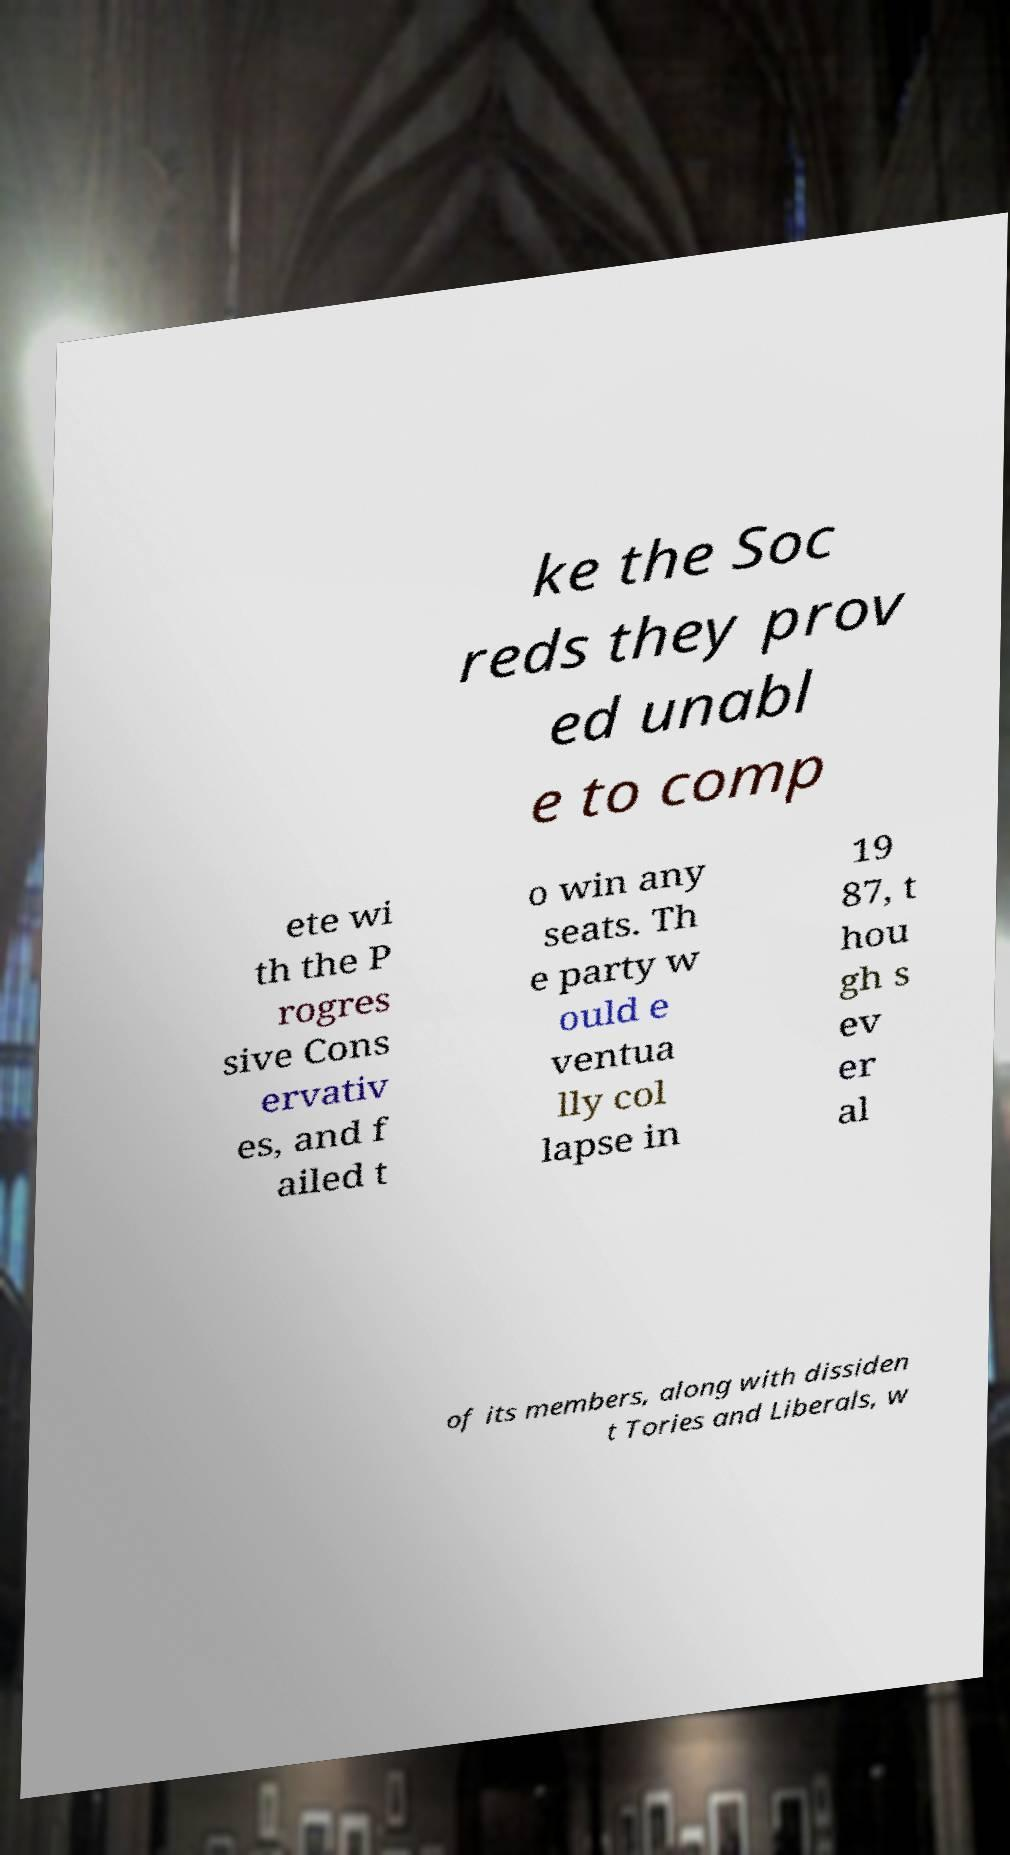Could you assist in decoding the text presented in this image and type it out clearly? ke the Soc reds they prov ed unabl e to comp ete wi th the P rogres sive Cons ervativ es, and f ailed t o win any seats. Th e party w ould e ventua lly col lapse in 19 87, t hou gh s ev er al of its members, along with dissiden t Tories and Liberals, w 